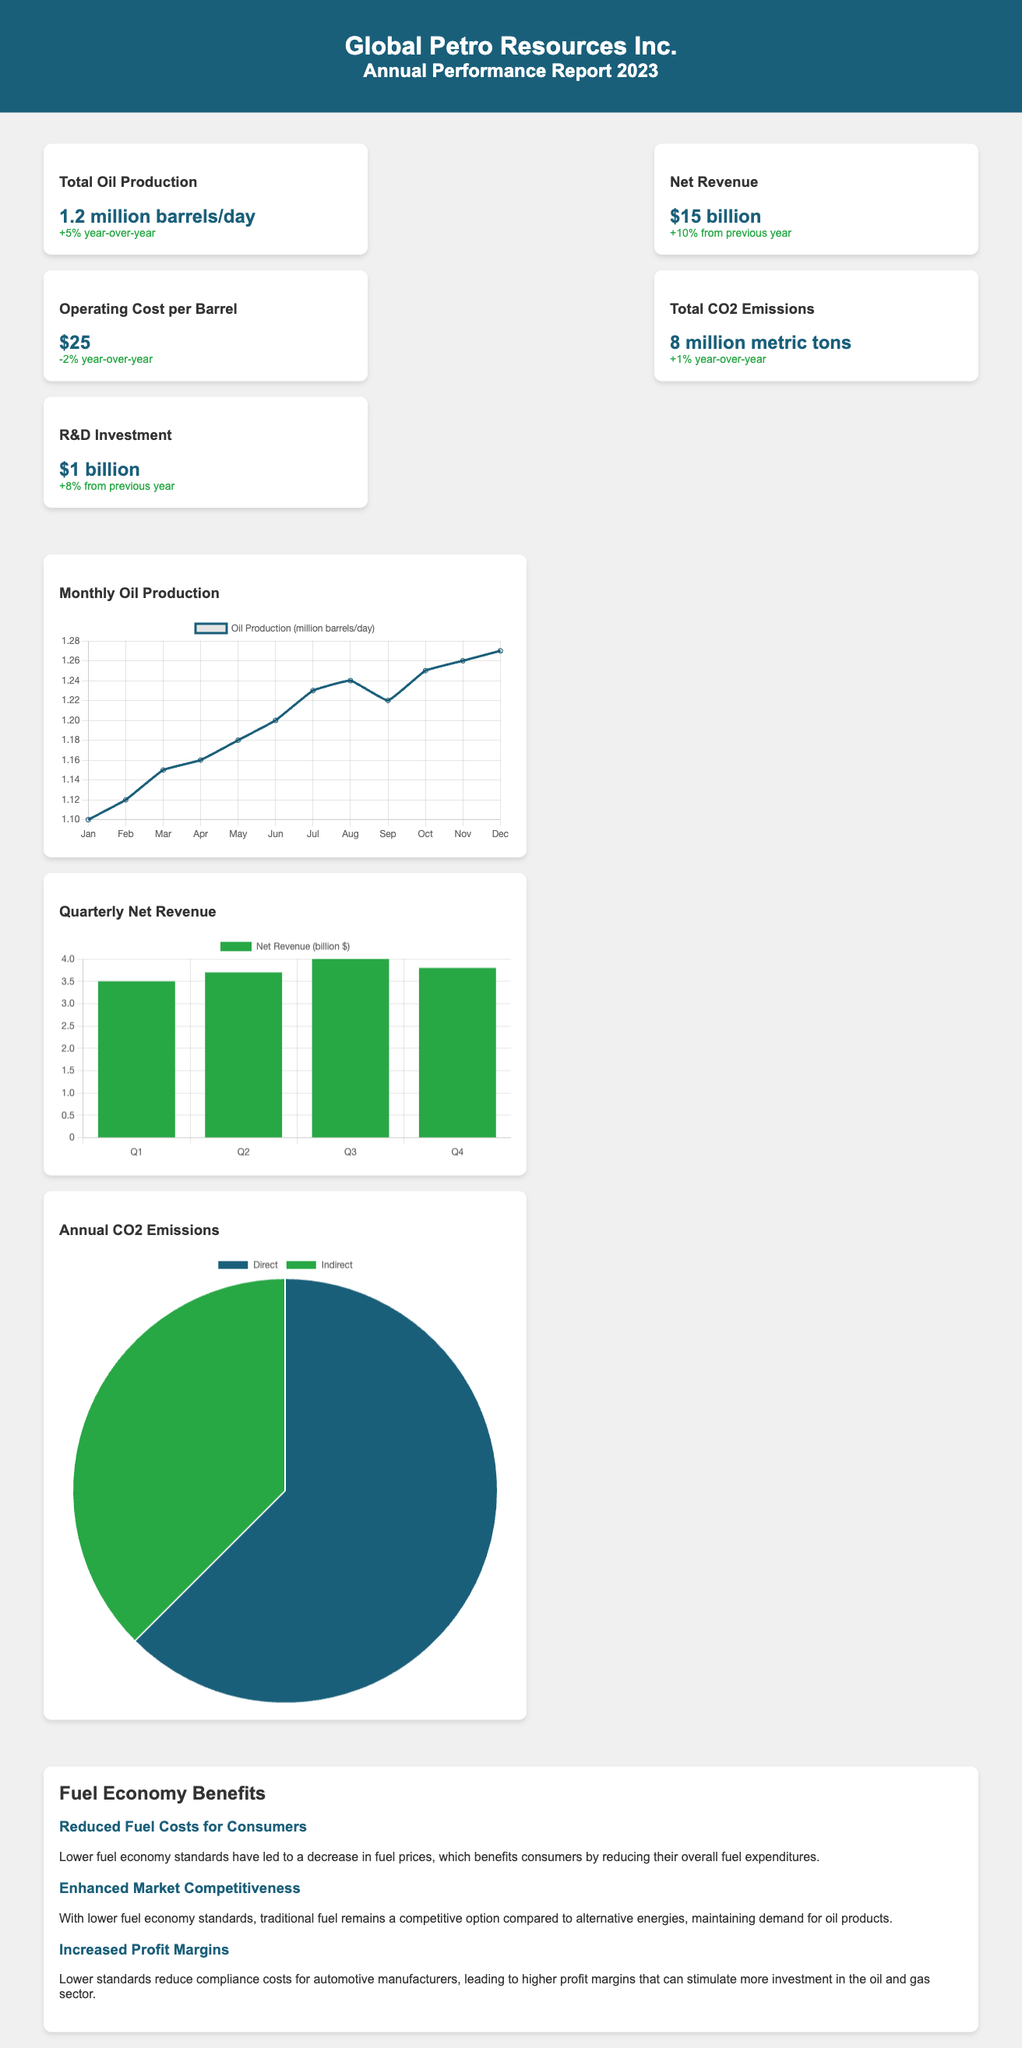What is the total oil production? The total oil production is stated clearly in the metrics section of the document, which is 1.2 million barrels/day.
Answer: 1.2 million barrels/day What is the net revenue? The net revenue mentioned in the report is found in the metrics section, which indicates $15 billion.
Answer: $15 billion What is the operating cost per barrel? According to the metrics, the operating cost per barrel is shown as $25.
Answer: $25 What percentage change did the total oil production experience? The performance report states that total oil production increased by 5% year-over-year.
Answer: +5% What is the total CO2 emissions mentioned? The document specifies the total CO2 emissions as 8 million metric tons.
Answer: 8 million metric tons How much is the R&D investment? The metrics section provides the R&D investment figure, which is $1 billion.
Answer: $1 billion What type of chart is used for monthly oil production? The visual representation for monthly oil production is presented as a line chart in the document.
Answer: Line chart What benefits does reduced fuel costs provide? The document explains that reduced fuel costs for consumers lead to decreased fuel expenditures overall.
Answer: Decreased fuel expenditures What does enhanced market competitiveness maintain? The report indicates that enhanced market competitiveness maintains demand for oil products.
Answer: Demand for oil products 